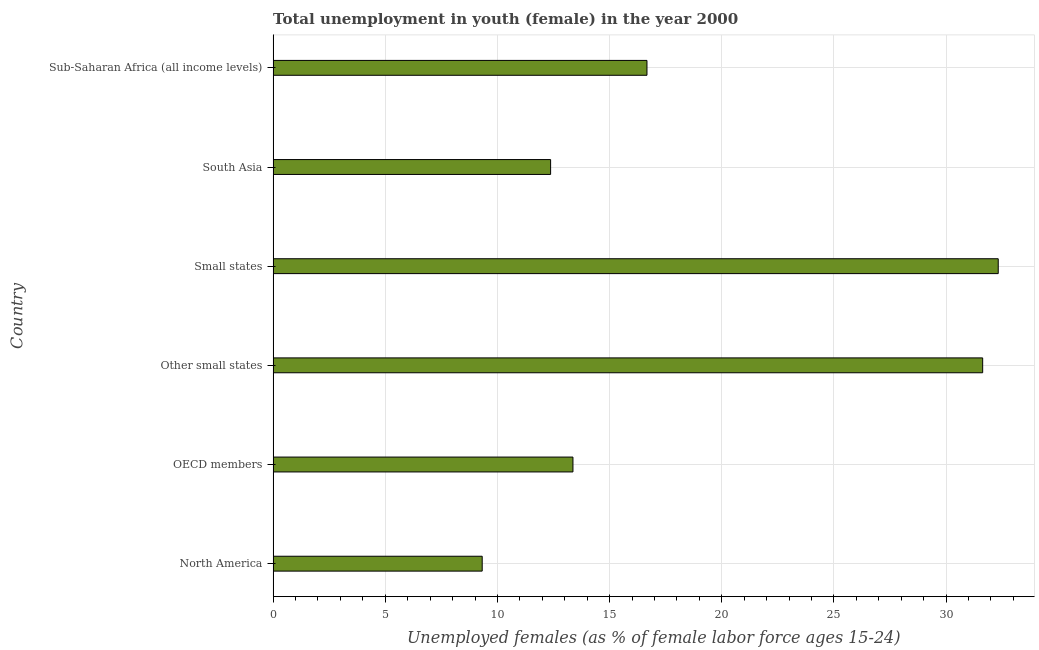What is the title of the graph?
Provide a short and direct response. Total unemployment in youth (female) in the year 2000. What is the label or title of the X-axis?
Your answer should be very brief. Unemployed females (as % of female labor force ages 15-24). What is the unemployed female youth population in South Asia?
Your answer should be compact. 12.37. Across all countries, what is the maximum unemployed female youth population?
Keep it short and to the point. 32.32. Across all countries, what is the minimum unemployed female youth population?
Provide a short and direct response. 9.32. In which country was the unemployed female youth population maximum?
Your response must be concise. Small states. What is the sum of the unemployed female youth population?
Your answer should be compact. 115.67. What is the difference between the unemployed female youth population in Other small states and Sub-Saharan Africa (all income levels)?
Offer a terse response. 14.96. What is the average unemployed female youth population per country?
Your answer should be very brief. 19.28. What is the median unemployed female youth population?
Your response must be concise. 15.02. In how many countries, is the unemployed female youth population greater than 7 %?
Ensure brevity in your answer.  6. What is the ratio of the unemployed female youth population in Other small states to that in South Asia?
Give a very brief answer. 2.56. Is the unemployed female youth population in North America less than that in Other small states?
Give a very brief answer. Yes. Is the difference between the unemployed female youth population in Small states and Sub-Saharan Africa (all income levels) greater than the difference between any two countries?
Your answer should be compact. No. What is the difference between the highest and the second highest unemployed female youth population?
Keep it short and to the point. 0.69. What is the difference between the highest and the lowest unemployed female youth population?
Offer a terse response. 23. How many bars are there?
Your answer should be compact. 6. What is the Unemployed females (as % of female labor force ages 15-24) of North America?
Ensure brevity in your answer.  9.32. What is the Unemployed females (as % of female labor force ages 15-24) of OECD members?
Provide a short and direct response. 13.37. What is the Unemployed females (as % of female labor force ages 15-24) in Other small states?
Make the answer very short. 31.63. What is the Unemployed females (as % of female labor force ages 15-24) in Small states?
Keep it short and to the point. 32.32. What is the Unemployed females (as % of female labor force ages 15-24) of South Asia?
Ensure brevity in your answer.  12.37. What is the Unemployed females (as % of female labor force ages 15-24) in Sub-Saharan Africa (all income levels)?
Give a very brief answer. 16.66. What is the difference between the Unemployed females (as % of female labor force ages 15-24) in North America and OECD members?
Your answer should be compact. -4.05. What is the difference between the Unemployed females (as % of female labor force ages 15-24) in North America and Other small states?
Provide a succinct answer. -22.31. What is the difference between the Unemployed females (as % of female labor force ages 15-24) in North America and Small states?
Your answer should be compact. -23. What is the difference between the Unemployed females (as % of female labor force ages 15-24) in North America and South Asia?
Your response must be concise. -3.05. What is the difference between the Unemployed females (as % of female labor force ages 15-24) in North America and Sub-Saharan Africa (all income levels)?
Offer a very short reply. -7.34. What is the difference between the Unemployed females (as % of female labor force ages 15-24) in OECD members and Other small states?
Your answer should be very brief. -18.26. What is the difference between the Unemployed females (as % of female labor force ages 15-24) in OECD members and Small states?
Give a very brief answer. -18.96. What is the difference between the Unemployed females (as % of female labor force ages 15-24) in OECD members and South Asia?
Ensure brevity in your answer.  1. What is the difference between the Unemployed females (as % of female labor force ages 15-24) in OECD members and Sub-Saharan Africa (all income levels)?
Offer a terse response. -3.3. What is the difference between the Unemployed females (as % of female labor force ages 15-24) in Other small states and Small states?
Provide a succinct answer. -0.69. What is the difference between the Unemployed females (as % of female labor force ages 15-24) in Other small states and South Asia?
Make the answer very short. 19.26. What is the difference between the Unemployed females (as % of female labor force ages 15-24) in Other small states and Sub-Saharan Africa (all income levels)?
Offer a very short reply. 14.96. What is the difference between the Unemployed females (as % of female labor force ages 15-24) in Small states and South Asia?
Offer a very short reply. 19.95. What is the difference between the Unemployed females (as % of female labor force ages 15-24) in Small states and Sub-Saharan Africa (all income levels)?
Offer a very short reply. 15.66. What is the difference between the Unemployed females (as % of female labor force ages 15-24) in South Asia and Sub-Saharan Africa (all income levels)?
Your answer should be very brief. -4.3. What is the ratio of the Unemployed females (as % of female labor force ages 15-24) in North America to that in OECD members?
Your answer should be very brief. 0.7. What is the ratio of the Unemployed females (as % of female labor force ages 15-24) in North America to that in Other small states?
Your response must be concise. 0.29. What is the ratio of the Unemployed females (as % of female labor force ages 15-24) in North America to that in Small states?
Give a very brief answer. 0.29. What is the ratio of the Unemployed females (as % of female labor force ages 15-24) in North America to that in South Asia?
Your response must be concise. 0.75. What is the ratio of the Unemployed females (as % of female labor force ages 15-24) in North America to that in Sub-Saharan Africa (all income levels)?
Make the answer very short. 0.56. What is the ratio of the Unemployed females (as % of female labor force ages 15-24) in OECD members to that in Other small states?
Provide a short and direct response. 0.42. What is the ratio of the Unemployed females (as % of female labor force ages 15-24) in OECD members to that in Small states?
Ensure brevity in your answer.  0.41. What is the ratio of the Unemployed females (as % of female labor force ages 15-24) in OECD members to that in South Asia?
Provide a short and direct response. 1.08. What is the ratio of the Unemployed females (as % of female labor force ages 15-24) in OECD members to that in Sub-Saharan Africa (all income levels)?
Offer a terse response. 0.8. What is the ratio of the Unemployed females (as % of female labor force ages 15-24) in Other small states to that in South Asia?
Your answer should be very brief. 2.56. What is the ratio of the Unemployed females (as % of female labor force ages 15-24) in Other small states to that in Sub-Saharan Africa (all income levels)?
Your answer should be very brief. 1.9. What is the ratio of the Unemployed females (as % of female labor force ages 15-24) in Small states to that in South Asia?
Provide a succinct answer. 2.61. What is the ratio of the Unemployed females (as % of female labor force ages 15-24) in Small states to that in Sub-Saharan Africa (all income levels)?
Provide a short and direct response. 1.94. What is the ratio of the Unemployed females (as % of female labor force ages 15-24) in South Asia to that in Sub-Saharan Africa (all income levels)?
Provide a short and direct response. 0.74. 